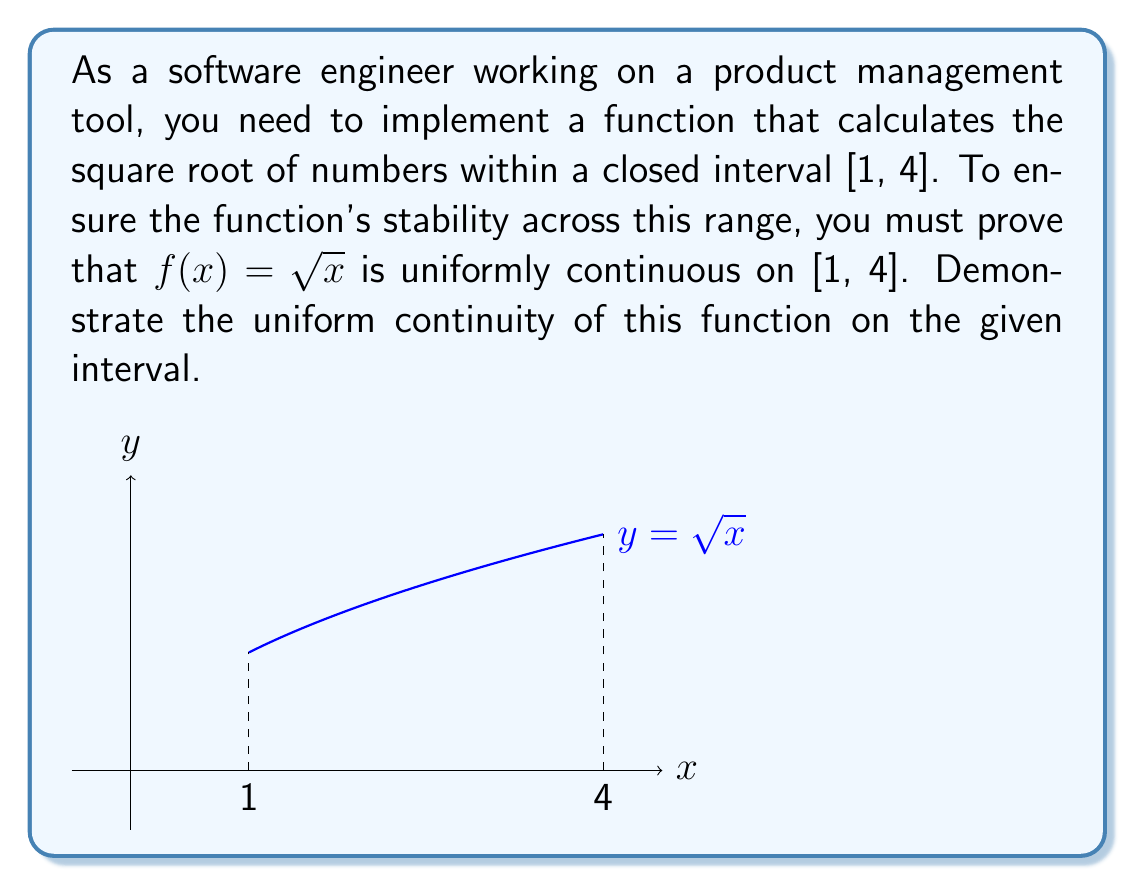Solve this math problem. To demonstrate uniform continuity of $f(x) = \sqrt{x}$ on [1, 4], we need to show that for any $\epsilon > 0$, there exists a $\delta > 0$ such that for all $x, y \in [1, 4]$, if $|x - y| < \delta$, then $|f(x) - f(y)| < \epsilon$.

Step 1: Express $|f(x) - f(y)|$ in terms of $|x - y|$
$$|\sqrt{x} - \sqrt{y}| = \frac{|x - y|}{\sqrt{x} + \sqrt{y}}$$

Step 2: Find a lower bound for $\sqrt{x} + \sqrt{y}$ on [1, 4]
Since $x, y \in [1, 4]$, we know that $\sqrt{x} + \sqrt{y} \geq 2\sqrt{1} = 2$

Step 3: Use the lower bound to establish an inequality
$$|\sqrt{x} - \sqrt{y}| = \frac{|x - y|}{\sqrt{x} + \sqrt{y}} \leq \frac{|x - y|}{2}$$

Step 4: Choose $\delta$ in terms of $\epsilon$
Let $\delta = 2\epsilon$. Then:

If $|x - y| < \delta = 2\epsilon$, we have:
$$|\sqrt{x} - \sqrt{y}| \leq \frac{|x - y|}{2} < \frac{2\epsilon}{2} = \epsilon$$

Step 5: Conclude uniform continuity
We have shown that for any $\epsilon > 0$, we can choose $\delta = 2\epsilon$ such that for all $x, y \in [1, 4]$, if $|x - y| < \delta$, then $|f(x) - f(y)| < \epsilon$. This demonstrates that $f(x) = \sqrt{x}$ is uniformly continuous on [1, 4].
Answer: $f(x) = \sqrt{x}$ is uniformly continuous on [1, 4] with $\delta = 2\epsilon$. 